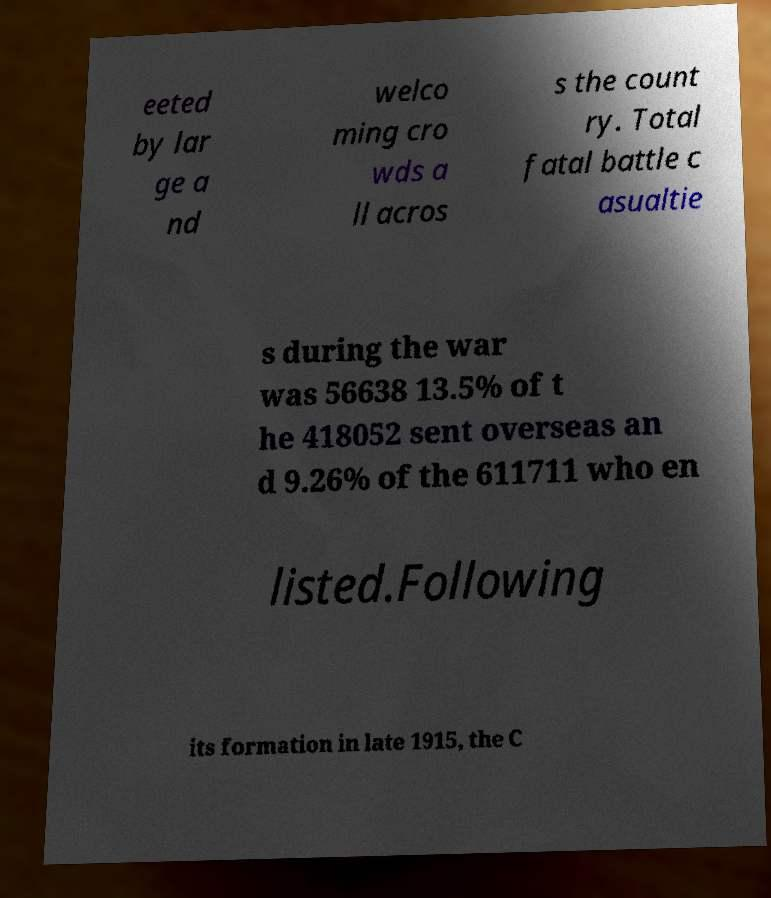Can you accurately transcribe the text from the provided image for me? eeted by lar ge a nd welco ming cro wds a ll acros s the count ry. Total fatal battle c asualtie s during the war was 56638 13.5% of t he 418052 sent overseas an d 9.26% of the 611711 who en listed.Following its formation in late 1915, the C 